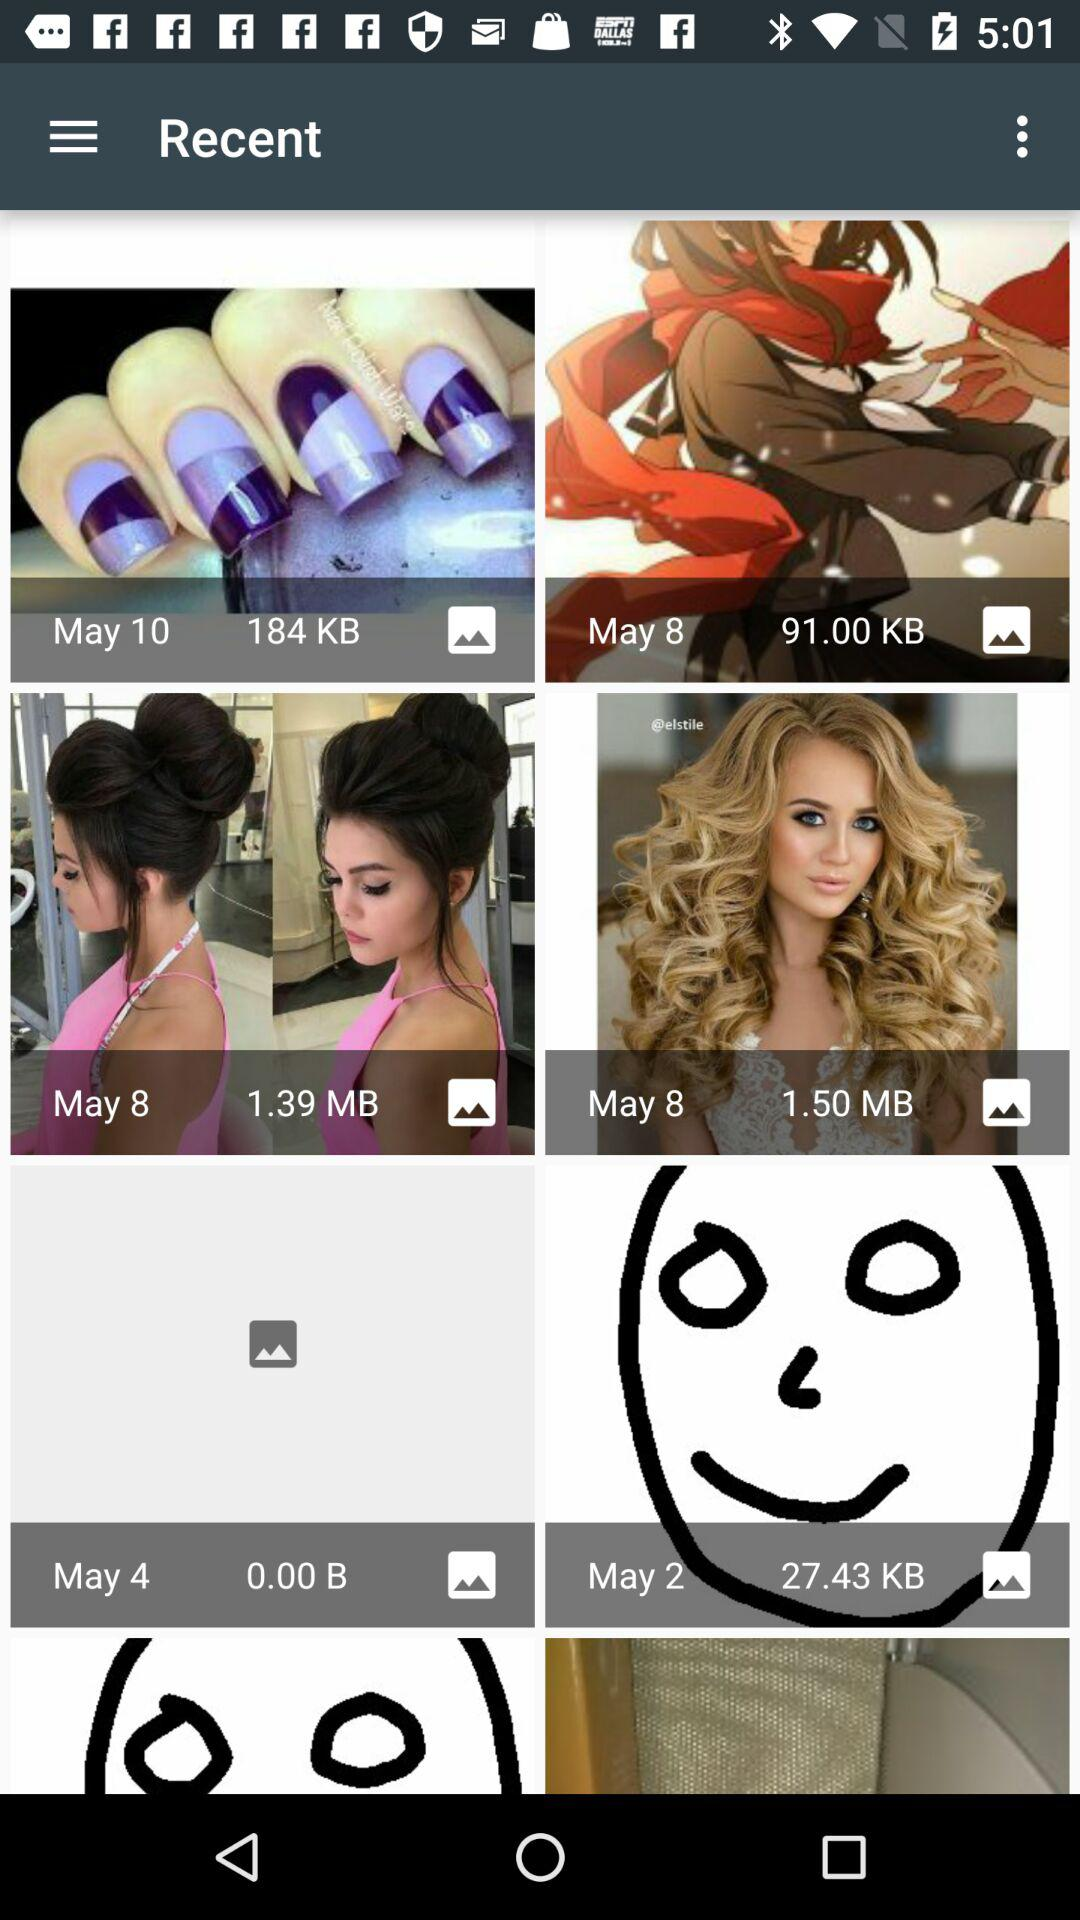How much memory is consumed by the folder dated May 10? The amount of memory consumed by the folder dated May 10 is 184 KB. 